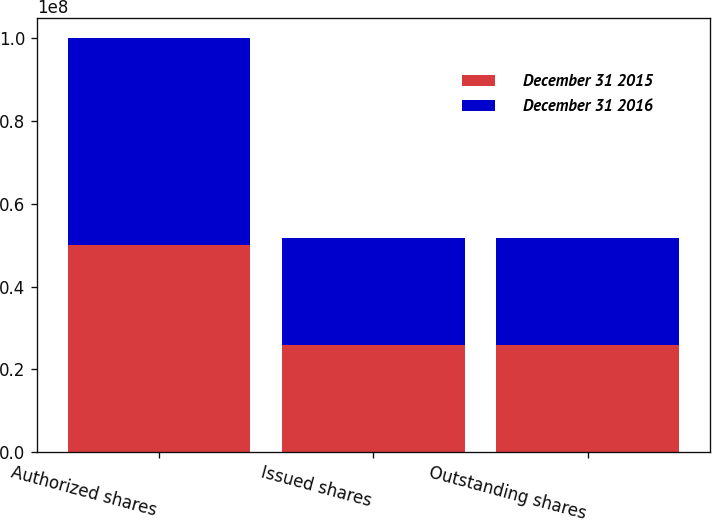Convert chart to OTSL. <chart><loc_0><loc_0><loc_500><loc_500><stacked_bar_chart><ecel><fcel>Authorized shares<fcel>Issued shares<fcel>Outstanding shares<nl><fcel>December 31 2015<fcel>5e+07<fcel>2.5875e+07<fcel>2.5875e+07<nl><fcel>December 31 2016<fcel>5e+07<fcel>2.5875e+07<fcel>2.5875e+07<nl></chart> 